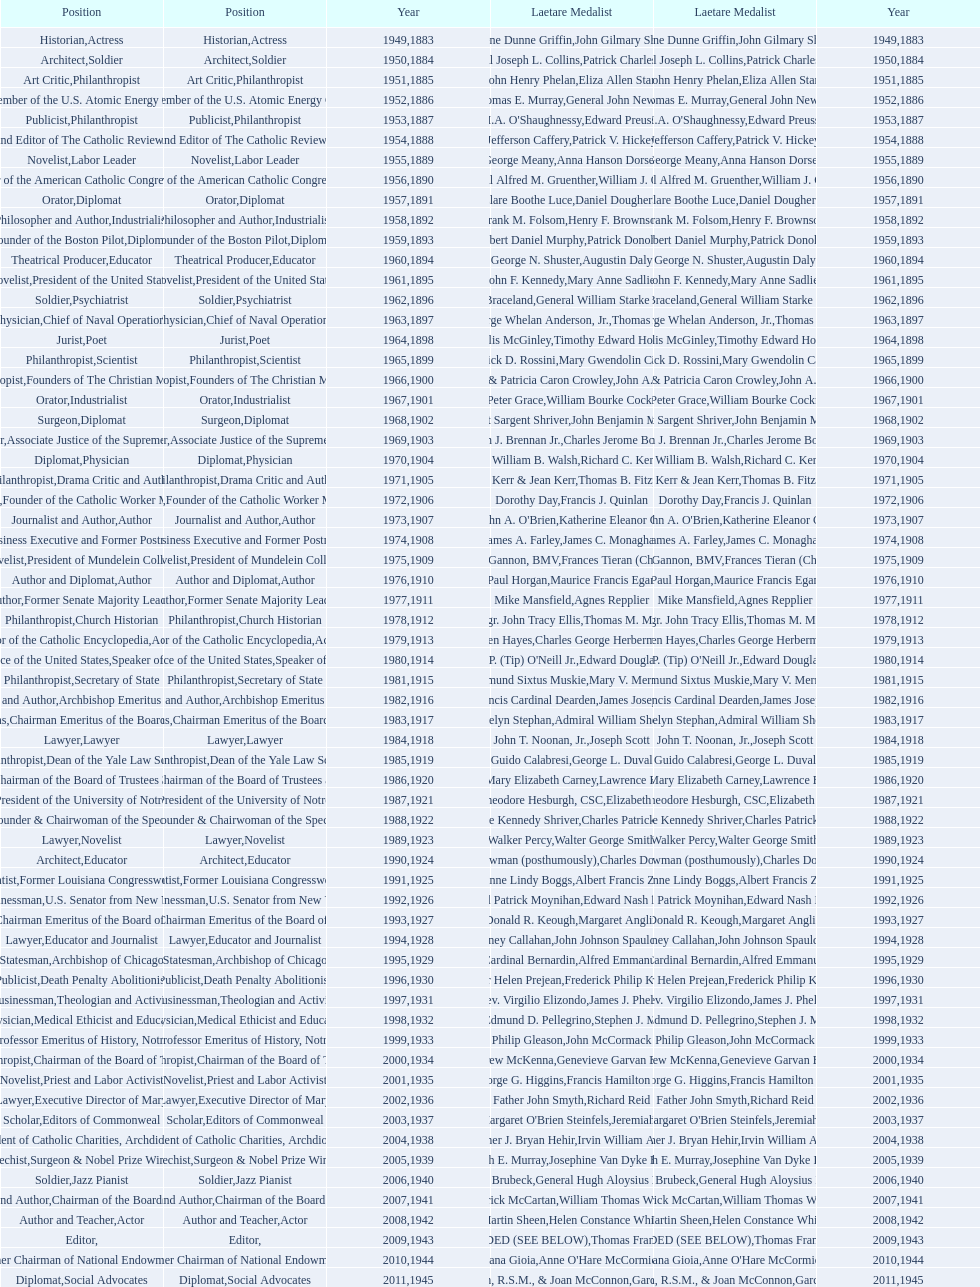What are the number of laetare medalist that held a diplomat position? 8. 